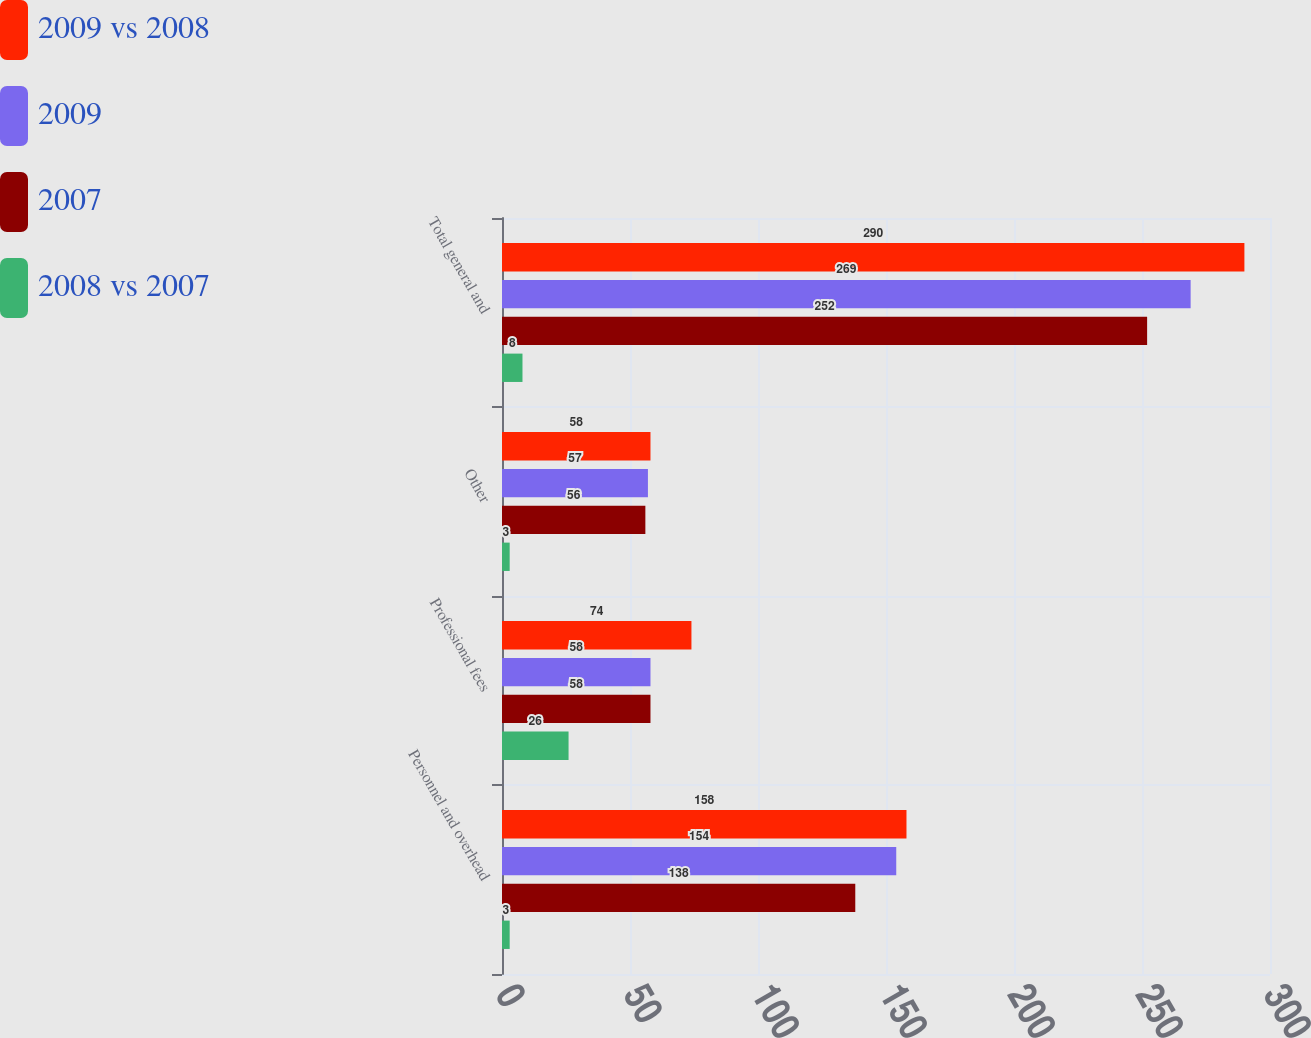<chart> <loc_0><loc_0><loc_500><loc_500><stacked_bar_chart><ecel><fcel>Personnel and overhead<fcel>Professional fees<fcel>Other<fcel>Total general and<nl><fcel>2009 vs 2008<fcel>158<fcel>74<fcel>58<fcel>290<nl><fcel>2009<fcel>154<fcel>58<fcel>57<fcel>269<nl><fcel>2007<fcel>138<fcel>58<fcel>56<fcel>252<nl><fcel>2008 vs 2007<fcel>3<fcel>26<fcel>3<fcel>8<nl></chart> 